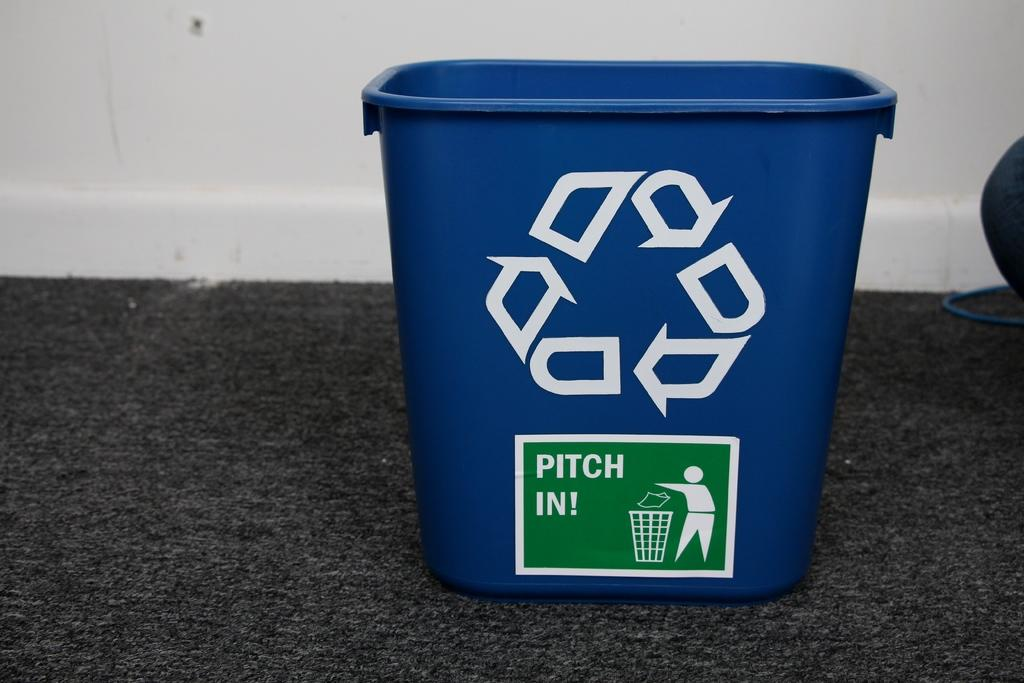<image>
Write a terse but informative summary of the picture. The recycle bin says pitch in on the bottom 